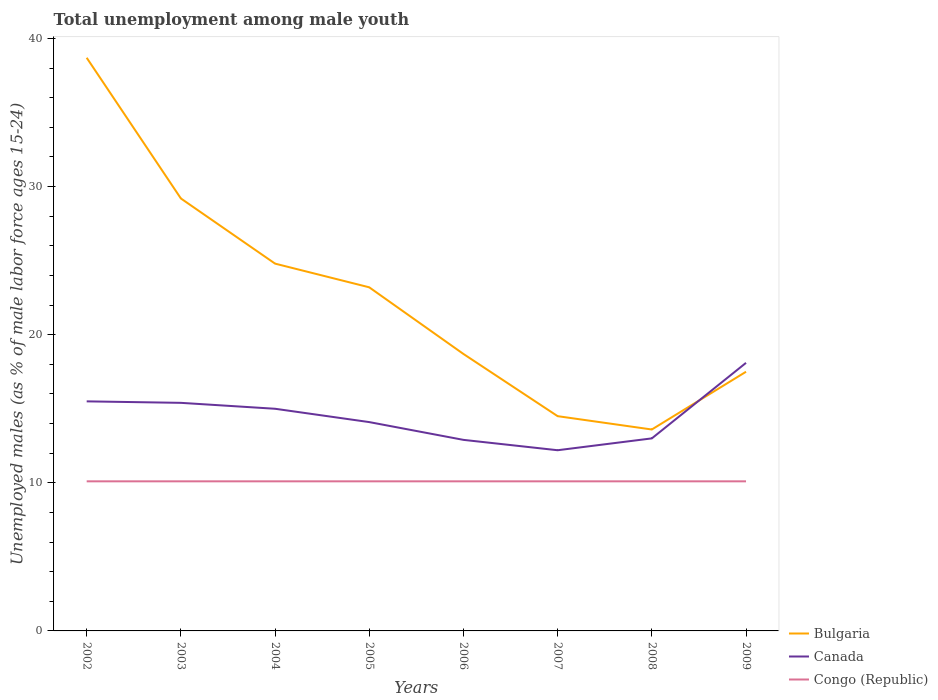How many different coloured lines are there?
Provide a succinct answer. 3. Does the line corresponding to Bulgaria intersect with the line corresponding to Canada?
Provide a succinct answer. Yes. Is the number of lines equal to the number of legend labels?
Your response must be concise. Yes. Across all years, what is the maximum percentage of unemployed males in in Canada?
Your answer should be compact. 12.2. In which year was the percentage of unemployed males in in Canada maximum?
Offer a terse response. 2007. What is the total percentage of unemployed males in in Bulgaria in the graph?
Your answer should be very brief. 24.2. What is the difference between the highest and the second highest percentage of unemployed males in in Congo (Republic)?
Provide a succinct answer. 0. Is the percentage of unemployed males in in Congo (Republic) strictly greater than the percentage of unemployed males in in Canada over the years?
Offer a terse response. Yes. How many years are there in the graph?
Offer a very short reply. 8. Are the values on the major ticks of Y-axis written in scientific E-notation?
Provide a short and direct response. No. Does the graph contain grids?
Offer a very short reply. No. Where does the legend appear in the graph?
Your answer should be very brief. Bottom right. How many legend labels are there?
Make the answer very short. 3. What is the title of the graph?
Your answer should be very brief. Total unemployment among male youth. Does "Faeroe Islands" appear as one of the legend labels in the graph?
Your response must be concise. No. What is the label or title of the Y-axis?
Give a very brief answer. Unemployed males (as % of male labor force ages 15-24). What is the Unemployed males (as % of male labor force ages 15-24) in Bulgaria in 2002?
Ensure brevity in your answer.  38.7. What is the Unemployed males (as % of male labor force ages 15-24) in Canada in 2002?
Offer a terse response. 15.5. What is the Unemployed males (as % of male labor force ages 15-24) in Congo (Republic) in 2002?
Provide a succinct answer. 10.1. What is the Unemployed males (as % of male labor force ages 15-24) in Bulgaria in 2003?
Make the answer very short. 29.2. What is the Unemployed males (as % of male labor force ages 15-24) of Canada in 2003?
Ensure brevity in your answer.  15.4. What is the Unemployed males (as % of male labor force ages 15-24) of Congo (Republic) in 2003?
Offer a very short reply. 10.1. What is the Unemployed males (as % of male labor force ages 15-24) of Bulgaria in 2004?
Your answer should be very brief. 24.8. What is the Unemployed males (as % of male labor force ages 15-24) in Canada in 2004?
Provide a short and direct response. 15. What is the Unemployed males (as % of male labor force ages 15-24) in Congo (Republic) in 2004?
Your answer should be compact. 10.1. What is the Unemployed males (as % of male labor force ages 15-24) of Bulgaria in 2005?
Your answer should be very brief. 23.2. What is the Unemployed males (as % of male labor force ages 15-24) in Canada in 2005?
Keep it short and to the point. 14.1. What is the Unemployed males (as % of male labor force ages 15-24) of Congo (Republic) in 2005?
Make the answer very short. 10.1. What is the Unemployed males (as % of male labor force ages 15-24) in Bulgaria in 2006?
Provide a short and direct response. 18.7. What is the Unemployed males (as % of male labor force ages 15-24) of Canada in 2006?
Your answer should be very brief. 12.9. What is the Unemployed males (as % of male labor force ages 15-24) in Congo (Republic) in 2006?
Ensure brevity in your answer.  10.1. What is the Unemployed males (as % of male labor force ages 15-24) of Bulgaria in 2007?
Offer a very short reply. 14.5. What is the Unemployed males (as % of male labor force ages 15-24) of Canada in 2007?
Give a very brief answer. 12.2. What is the Unemployed males (as % of male labor force ages 15-24) in Congo (Republic) in 2007?
Make the answer very short. 10.1. What is the Unemployed males (as % of male labor force ages 15-24) in Bulgaria in 2008?
Your answer should be very brief. 13.6. What is the Unemployed males (as % of male labor force ages 15-24) of Congo (Republic) in 2008?
Your answer should be very brief. 10.1. What is the Unemployed males (as % of male labor force ages 15-24) in Bulgaria in 2009?
Provide a succinct answer. 17.5. What is the Unemployed males (as % of male labor force ages 15-24) of Canada in 2009?
Your answer should be very brief. 18.1. What is the Unemployed males (as % of male labor force ages 15-24) of Congo (Republic) in 2009?
Your answer should be compact. 10.1. Across all years, what is the maximum Unemployed males (as % of male labor force ages 15-24) of Bulgaria?
Offer a terse response. 38.7. Across all years, what is the maximum Unemployed males (as % of male labor force ages 15-24) in Canada?
Make the answer very short. 18.1. Across all years, what is the maximum Unemployed males (as % of male labor force ages 15-24) of Congo (Republic)?
Your answer should be very brief. 10.1. Across all years, what is the minimum Unemployed males (as % of male labor force ages 15-24) of Bulgaria?
Provide a succinct answer. 13.6. Across all years, what is the minimum Unemployed males (as % of male labor force ages 15-24) of Canada?
Keep it short and to the point. 12.2. Across all years, what is the minimum Unemployed males (as % of male labor force ages 15-24) in Congo (Republic)?
Provide a succinct answer. 10.1. What is the total Unemployed males (as % of male labor force ages 15-24) of Bulgaria in the graph?
Ensure brevity in your answer.  180.2. What is the total Unemployed males (as % of male labor force ages 15-24) of Canada in the graph?
Give a very brief answer. 116.2. What is the total Unemployed males (as % of male labor force ages 15-24) of Congo (Republic) in the graph?
Give a very brief answer. 80.8. What is the difference between the Unemployed males (as % of male labor force ages 15-24) in Bulgaria in 2002 and that in 2003?
Give a very brief answer. 9.5. What is the difference between the Unemployed males (as % of male labor force ages 15-24) in Bulgaria in 2002 and that in 2004?
Provide a short and direct response. 13.9. What is the difference between the Unemployed males (as % of male labor force ages 15-24) in Canada in 2002 and that in 2004?
Make the answer very short. 0.5. What is the difference between the Unemployed males (as % of male labor force ages 15-24) of Bulgaria in 2002 and that in 2005?
Offer a terse response. 15.5. What is the difference between the Unemployed males (as % of male labor force ages 15-24) of Congo (Republic) in 2002 and that in 2005?
Keep it short and to the point. 0. What is the difference between the Unemployed males (as % of male labor force ages 15-24) in Bulgaria in 2002 and that in 2006?
Your answer should be very brief. 20. What is the difference between the Unemployed males (as % of male labor force ages 15-24) of Congo (Republic) in 2002 and that in 2006?
Provide a short and direct response. 0. What is the difference between the Unemployed males (as % of male labor force ages 15-24) in Bulgaria in 2002 and that in 2007?
Keep it short and to the point. 24.2. What is the difference between the Unemployed males (as % of male labor force ages 15-24) in Canada in 2002 and that in 2007?
Your response must be concise. 3.3. What is the difference between the Unemployed males (as % of male labor force ages 15-24) in Congo (Republic) in 2002 and that in 2007?
Ensure brevity in your answer.  0. What is the difference between the Unemployed males (as % of male labor force ages 15-24) of Bulgaria in 2002 and that in 2008?
Your response must be concise. 25.1. What is the difference between the Unemployed males (as % of male labor force ages 15-24) of Canada in 2002 and that in 2008?
Offer a terse response. 2.5. What is the difference between the Unemployed males (as % of male labor force ages 15-24) of Bulgaria in 2002 and that in 2009?
Offer a terse response. 21.2. What is the difference between the Unemployed males (as % of male labor force ages 15-24) in Canada in 2002 and that in 2009?
Make the answer very short. -2.6. What is the difference between the Unemployed males (as % of male labor force ages 15-24) in Congo (Republic) in 2003 and that in 2004?
Give a very brief answer. 0. What is the difference between the Unemployed males (as % of male labor force ages 15-24) in Canada in 2003 and that in 2005?
Give a very brief answer. 1.3. What is the difference between the Unemployed males (as % of male labor force ages 15-24) of Bulgaria in 2003 and that in 2006?
Give a very brief answer. 10.5. What is the difference between the Unemployed males (as % of male labor force ages 15-24) in Canada in 2003 and that in 2006?
Provide a succinct answer. 2.5. What is the difference between the Unemployed males (as % of male labor force ages 15-24) of Bulgaria in 2003 and that in 2007?
Ensure brevity in your answer.  14.7. What is the difference between the Unemployed males (as % of male labor force ages 15-24) in Congo (Republic) in 2003 and that in 2009?
Offer a terse response. 0. What is the difference between the Unemployed males (as % of male labor force ages 15-24) in Bulgaria in 2004 and that in 2005?
Make the answer very short. 1.6. What is the difference between the Unemployed males (as % of male labor force ages 15-24) of Bulgaria in 2004 and that in 2006?
Give a very brief answer. 6.1. What is the difference between the Unemployed males (as % of male labor force ages 15-24) in Congo (Republic) in 2004 and that in 2006?
Offer a terse response. 0. What is the difference between the Unemployed males (as % of male labor force ages 15-24) of Bulgaria in 2004 and that in 2007?
Offer a very short reply. 10.3. What is the difference between the Unemployed males (as % of male labor force ages 15-24) of Canada in 2004 and that in 2007?
Offer a very short reply. 2.8. What is the difference between the Unemployed males (as % of male labor force ages 15-24) in Congo (Republic) in 2004 and that in 2007?
Your answer should be very brief. 0. What is the difference between the Unemployed males (as % of male labor force ages 15-24) in Bulgaria in 2004 and that in 2008?
Offer a very short reply. 11.2. What is the difference between the Unemployed males (as % of male labor force ages 15-24) of Canada in 2004 and that in 2008?
Make the answer very short. 2. What is the difference between the Unemployed males (as % of male labor force ages 15-24) of Bulgaria in 2004 and that in 2009?
Offer a terse response. 7.3. What is the difference between the Unemployed males (as % of male labor force ages 15-24) of Congo (Republic) in 2004 and that in 2009?
Offer a terse response. 0. What is the difference between the Unemployed males (as % of male labor force ages 15-24) of Bulgaria in 2005 and that in 2006?
Keep it short and to the point. 4.5. What is the difference between the Unemployed males (as % of male labor force ages 15-24) in Canada in 2005 and that in 2006?
Keep it short and to the point. 1.2. What is the difference between the Unemployed males (as % of male labor force ages 15-24) in Congo (Republic) in 2005 and that in 2006?
Your response must be concise. 0. What is the difference between the Unemployed males (as % of male labor force ages 15-24) of Canada in 2005 and that in 2007?
Provide a short and direct response. 1.9. What is the difference between the Unemployed males (as % of male labor force ages 15-24) in Congo (Republic) in 2005 and that in 2007?
Provide a succinct answer. 0. What is the difference between the Unemployed males (as % of male labor force ages 15-24) of Congo (Republic) in 2005 and that in 2008?
Your answer should be compact. 0. What is the difference between the Unemployed males (as % of male labor force ages 15-24) of Canada in 2005 and that in 2009?
Give a very brief answer. -4. What is the difference between the Unemployed males (as % of male labor force ages 15-24) of Congo (Republic) in 2005 and that in 2009?
Make the answer very short. 0. What is the difference between the Unemployed males (as % of male labor force ages 15-24) in Bulgaria in 2006 and that in 2009?
Offer a very short reply. 1.2. What is the difference between the Unemployed males (as % of male labor force ages 15-24) of Congo (Republic) in 2007 and that in 2008?
Offer a terse response. 0. What is the difference between the Unemployed males (as % of male labor force ages 15-24) in Bulgaria in 2007 and that in 2009?
Keep it short and to the point. -3. What is the difference between the Unemployed males (as % of male labor force ages 15-24) of Bulgaria in 2008 and that in 2009?
Provide a succinct answer. -3.9. What is the difference between the Unemployed males (as % of male labor force ages 15-24) of Bulgaria in 2002 and the Unemployed males (as % of male labor force ages 15-24) of Canada in 2003?
Your response must be concise. 23.3. What is the difference between the Unemployed males (as % of male labor force ages 15-24) in Bulgaria in 2002 and the Unemployed males (as % of male labor force ages 15-24) in Congo (Republic) in 2003?
Keep it short and to the point. 28.6. What is the difference between the Unemployed males (as % of male labor force ages 15-24) of Canada in 2002 and the Unemployed males (as % of male labor force ages 15-24) of Congo (Republic) in 2003?
Give a very brief answer. 5.4. What is the difference between the Unemployed males (as % of male labor force ages 15-24) in Bulgaria in 2002 and the Unemployed males (as % of male labor force ages 15-24) in Canada in 2004?
Provide a succinct answer. 23.7. What is the difference between the Unemployed males (as % of male labor force ages 15-24) in Bulgaria in 2002 and the Unemployed males (as % of male labor force ages 15-24) in Congo (Republic) in 2004?
Provide a short and direct response. 28.6. What is the difference between the Unemployed males (as % of male labor force ages 15-24) in Bulgaria in 2002 and the Unemployed males (as % of male labor force ages 15-24) in Canada in 2005?
Ensure brevity in your answer.  24.6. What is the difference between the Unemployed males (as % of male labor force ages 15-24) of Bulgaria in 2002 and the Unemployed males (as % of male labor force ages 15-24) of Congo (Republic) in 2005?
Provide a short and direct response. 28.6. What is the difference between the Unemployed males (as % of male labor force ages 15-24) in Bulgaria in 2002 and the Unemployed males (as % of male labor force ages 15-24) in Canada in 2006?
Offer a terse response. 25.8. What is the difference between the Unemployed males (as % of male labor force ages 15-24) in Bulgaria in 2002 and the Unemployed males (as % of male labor force ages 15-24) in Congo (Republic) in 2006?
Ensure brevity in your answer.  28.6. What is the difference between the Unemployed males (as % of male labor force ages 15-24) of Bulgaria in 2002 and the Unemployed males (as % of male labor force ages 15-24) of Congo (Republic) in 2007?
Ensure brevity in your answer.  28.6. What is the difference between the Unemployed males (as % of male labor force ages 15-24) of Canada in 2002 and the Unemployed males (as % of male labor force ages 15-24) of Congo (Republic) in 2007?
Offer a very short reply. 5.4. What is the difference between the Unemployed males (as % of male labor force ages 15-24) of Bulgaria in 2002 and the Unemployed males (as % of male labor force ages 15-24) of Canada in 2008?
Your answer should be very brief. 25.7. What is the difference between the Unemployed males (as % of male labor force ages 15-24) in Bulgaria in 2002 and the Unemployed males (as % of male labor force ages 15-24) in Congo (Republic) in 2008?
Keep it short and to the point. 28.6. What is the difference between the Unemployed males (as % of male labor force ages 15-24) of Canada in 2002 and the Unemployed males (as % of male labor force ages 15-24) of Congo (Republic) in 2008?
Offer a terse response. 5.4. What is the difference between the Unemployed males (as % of male labor force ages 15-24) in Bulgaria in 2002 and the Unemployed males (as % of male labor force ages 15-24) in Canada in 2009?
Your answer should be very brief. 20.6. What is the difference between the Unemployed males (as % of male labor force ages 15-24) of Bulgaria in 2002 and the Unemployed males (as % of male labor force ages 15-24) of Congo (Republic) in 2009?
Give a very brief answer. 28.6. What is the difference between the Unemployed males (as % of male labor force ages 15-24) of Bulgaria in 2003 and the Unemployed males (as % of male labor force ages 15-24) of Congo (Republic) in 2004?
Offer a terse response. 19.1. What is the difference between the Unemployed males (as % of male labor force ages 15-24) of Canada in 2003 and the Unemployed males (as % of male labor force ages 15-24) of Congo (Republic) in 2004?
Your answer should be compact. 5.3. What is the difference between the Unemployed males (as % of male labor force ages 15-24) of Bulgaria in 2003 and the Unemployed males (as % of male labor force ages 15-24) of Canada in 2005?
Make the answer very short. 15.1. What is the difference between the Unemployed males (as % of male labor force ages 15-24) in Canada in 2003 and the Unemployed males (as % of male labor force ages 15-24) in Congo (Republic) in 2005?
Keep it short and to the point. 5.3. What is the difference between the Unemployed males (as % of male labor force ages 15-24) in Bulgaria in 2003 and the Unemployed males (as % of male labor force ages 15-24) in Canada in 2006?
Keep it short and to the point. 16.3. What is the difference between the Unemployed males (as % of male labor force ages 15-24) in Bulgaria in 2003 and the Unemployed males (as % of male labor force ages 15-24) in Canada in 2007?
Give a very brief answer. 17. What is the difference between the Unemployed males (as % of male labor force ages 15-24) of Bulgaria in 2003 and the Unemployed males (as % of male labor force ages 15-24) of Congo (Republic) in 2007?
Offer a very short reply. 19.1. What is the difference between the Unemployed males (as % of male labor force ages 15-24) in Canada in 2003 and the Unemployed males (as % of male labor force ages 15-24) in Congo (Republic) in 2007?
Give a very brief answer. 5.3. What is the difference between the Unemployed males (as % of male labor force ages 15-24) of Bulgaria in 2003 and the Unemployed males (as % of male labor force ages 15-24) of Canada in 2008?
Your answer should be compact. 16.2. What is the difference between the Unemployed males (as % of male labor force ages 15-24) of Bulgaria in 2003 and the Unemployed males (as % of male labor force ages 15-24) of Congo (Republic) in 2009?
Your answer should be compact. 19.1. What is the difference between the Unemployed males (as % of male labor force ages 15-24) of Bulgaria in 2004 and the Unemployed males (as % of male labor force ages 15-24) of Congo (Republic) in 2005?
Your answer should be compact. 14.7. What is the difference between the Unemployed males (as % of male labor force ages 15-24) in Bulgaria in 2004 and the Unemployed males (as % of male labor force ages 15-24) in Canada in 2006?
Give a very brief answer. 11.9. What is the difference between the Unemployed males (as % of male labor force ages 15-24) in Bulgaria in 2004 and the Unemployed males (as % of male labor force ages 15-24) in Canada in 2007?
Your answer should be very brief. 12.6. What is the difference between the Unemployed males (as % of male labor force ages 15-24) of Bulgaria in 2004 and the Unemployed males (as % of male labor force ages 15-24) of Congo (Republic) in 2007?
Offer a terse response. 14.7. What is the difference between the Unemployed males (as % of male labor force ages 15-24) of Canada in 2004 and the Unemployed males (as % of male labor force ages 15-24) of Congo (Republic) in 2007?
Give a very brief answer. 4.9. What is the difference between the Unemployed males (as % of male labor force ages 15-24) of Bulgaria in 2004 and the Unemployed males (as % of male labor force ages 15-24) of Canada in 2008?
Your answer should be very brief. 11.8. What is the difference between the Unemployed males (as % of male labor force ages 15-24) in Bulgaria in 2004 and the Unemployed males (as % of male labor force ages 15-24) in Canada in 2009?
Offer a very short reply. 6.7. What is the difference between the Unemployed males (as % of male labor force ages 15-24) in Bulgaria in 2004 and the Unemployed males (as % of male labor force ages 15-24) in Congo (Republic) in 2009?
Your response must be concise. 14.7. What is the difference between the Unemployed males (as % of male labor force ages 15-24) in Canada in 2004 and the Unemployed males (as % of male labor force ages 15-24) in Congo (Republic) in 2009?
Ensure brevity in your answer.  4.9. What is the difference between the Unemployed males (as % of male labor force ages 15-24) of Bulgaria in 2005 and the Unemployed males (as % of male labor force ages 15-24) of Canada in 2006?
Give a very brief answer. 10.3. What is the difference between the Unemployed males (as % of male labor force ages 15-24) in Bulgaria in 2005 and the Unemployed males (as % of male labor force ages 15-24) in Congo (Republic) in 2006?
Ensure brevity in your answer.  13.1. What is the difference between the Unemployed males (as % of male labor force ages 15-24) in Canada in 2005 and the Unemployed males (as % of male labor force ages 15-24) in Congo (Republic) in 2006?
Your answer should be compact. 4. What is the difference between the Unemployed males (as % of male labor force ages 15-24) in Canada in 2005 and the Unemployed males (as % of male labor force ages 15-24) in Congo (Republic) in 2007?
Your answer should be very brief. 4. What is the difference between the Unemployed males (as % of male labor force ages 15-24) in Bulgaria in 2005 and the Unemployed males (as % of male labor force ages 15-24) in Canada in 2008?
Ensure brevity in your answer.  10.2. What is the difference between the Unemployed males (as % of male labor force ages 15-24) in Bulgaria in 2005 and the Unemployed males (as % of male labor force ages 15-24) in Congo (Republic) in 2008?
Offer a very short reply. 13.1. What is the difference between the Unemployed males (as % of male labor force ages 15-24) of Bulgaria in 2005 and the Unemployed males (as % of male labor force ages 15-24) of Canada in 2009?
Provide a succinct answer. 5.1. What is the difference between the Unemployed males (as % of male labor force ages 15-24) in Bulgaria in 2005 and the Unemployed males (as % of male labor force ages 15-24) in Congo (Republic) in 2009?
Keep it short and to the point. 13.1. What is the difference between the Unemployed males (as % of male labor force ages 15-24) of Canada in 2006 and the Unemployed males (as % of male labor force ages 15-24) of Congo (Republic) in 2007?
Your answer should be compact. 2.8. What is the difference between the Unemployed males (as % of male labor force ages 15-24) of Canada in 2006 and the Unemployed males (as % of male labor force ages 15-24) of Congo (Republic) in 2008?
Your response must be concise. 2.8. What is the difference between the Unemployed males (as % of male labor force ages 15-24) in Canada in 2006 and the Unemployed males (as % of male labor force ages 15-24) in Congo (Republic) in 2009?
Your response must be concise. 2.8. What is the difference between the Unemployed males (as % of male labor force ages 15-24) in Bulgaria in 2007 and the Unemployed males (as % of male labor force ages 15-24) in Canada in 2008?
Keep it short and to the point. 1.5. What is the difference between the Unemployed males (as % of male labor force ages 15-24) of Bulgaria in 2007 and the Unemployed males (as % of male labor force ages 15-24) of Congo (Republic) in 2008?
Give a very brief answer. 4.4. What is the difference between the Unemployed males (as % of male labor force ages 15-24) in Canada in 2007 and the Unemployed males (as % of male labor force ages 15-24) in Congo (Republic) in 2008?
Offer a very short reply. 2.1. What is the difference between the Unemployed males (as % of male labor force ages 15-24) of Bulgaria in 2007 and the Unemployed males (as % of male labor force ages 15-24) of Canada in 2009?
Your response must be concise. -3.6. What is the difference between the Unemployed males (as % of male labor force ages 15-24) in Bulgaria in 2007 and the Unemployed males (as % of male labor force ages 15-24) in Congo (Republic) in 2009?
Offer a very short reply. 4.4. What is the difference between the Unemployed males (as % of male labor force ages 15-24) in Bulgaria in 2008 and the Unemployed males (as % of male labor force ages 15-24) in Canada in 2009?
Offer a very short reply. -4.5. What is the difference between the Unemployed males (as % of male labor force ages 15-24) in Bulgaria in 2008 and the Unemployed males (as % of male labor force ages 15-24) in Congo (Republic) in 2009?
Ensure brevity in your answer.  3.5. What is the difference between the Unemployed males (as % of male labor force ages 15-24) of Canada in 2008 and the Unemployed males (as % of male labor force ages 15-24) of Congo (Republic) in 2009?
Provide a short and direct response. 2.9. What is the average Unemployed males (as % of male labor force ages 15-24) in Bulgaria per year?
Your answer should be compact. 22.52. What is the average Unemployed males (as % of male labor force ages 15-24) of Canada per year?
Your answer should be very brief. 14.53. In the year 2002, what is the difference between the Unemployed males (as % of male labor force ages 15-24) of Bulgaria and Unemployed males (as % of male labor force ages 15-24) of Canada?
Ensure brevity in your answer.  23.2. In the year 2002, what is the difference between the Unemployed males (as % of male labor force ages 15-24) in Bulgaria and Unemployed males (as % of male labor force ages 15-24) in Congo (Republic)?
Give a very brief answer. 28.6. In the year 2003, what is the difference between the Unemployed males (as % of male labor force ages 15-24) of Bulgaria and Unemployed males (as % of male labor force ages 15-24) of Canada?
Offer a terse response. 13.8. In the year 2003, what is the difference between the Unemployed males (as % of male labor force ages 15-24) of Bulgaria and Unemployed males (as % of male labor force ages 15-24) of Congo (Republic)?
Your response must be concise. 19.1. In the year 2004, what is the difference between the Unemployed males (as % of male labor force ages 15-24) in Canada and Unemployed males (as % of male labor force ages 15-24) in Congo (Republic)?
Provide a short and direct response. 4.9. In the year 2006, what is the difference between the Unemployed males (as % of male labor force ages 15-24) of Bulgaria and Unemployed males (as % of male labor force ages 15-24) of Canada?
Your response must be concise. 5.8. In the year 2006, what is the difference between the Unemployed males (as % of male labor force ages 15-24) of Canada and Unemployed males (as % of male labor force ages 15-24) of Congo (Republic)?
Offer a very short reply. 2.8. In the year 2007, what is the difference between the Unemployed males (as % of male labor force ages 15-24) of Bulgaria and Unemployed males (as % of male labor force ages 15-24) of Congo (Republic)?
Your answer should be very brief. 4.4. In the year 2008, what is the difference between the Unemployed males (as % of male labor force ages 15-24) in Bulgaria and Unemployed males (as % of male labor force ages 15-24) in Congo (Republic)?
Make the answer very short. 3.5. What is the ratio of the Unemployed males (as % of male labor force ages 15-24) of Bulgaria in 2002 to that in 2003?
Offer a very short reply. 1.33. What is the ratio of the Unemployed males (as % of male labor force ages 15-24) of Congo (Republic) in 2002 to that in 2003?
Keep it short and to the point. 1. What is the ratio of the Unemployed males (as % of male labor force ages 15-24) in Bulgaria in 2002 to that in 2004?
Offer a terse response. 1.56. What is the ratio of the Unemployed males (as % of male labor force ages 15-24) of Congo (Republic) in 2002 to that in 2004?
Give a very brief answer. 1. What is the ratio of the Unemployed males (as % of male labor force ages 15-24) of Bulgaria in 2002 to that in 2005?
Make the answer very short. 1.67. What is the ratio of the Unemployed males (as % of male labor force ages 15-24) in Canada in 2002 to that in 2005?
Offer a very short reply. 1.1. What is the ratio of the Unemployed males (as % of male labor force ages 15-24) of Congo (Republic) in 2002 to that in 2005?
Offer a very short reply. 1. What is the ratio of the Unemployed males (as % of male labor force ages 15-24) of Bulgaria in 2002 to that in 2006?
Make the answer very short. 2.07. What is the ratio of the Unemployed males (as % of male labor force ages 15-24) in Canada in 2002 to that in 2006?
Offer a terse response. 1.2. What is the ratio of the Unemployed males (as % of male labor force ages 15-24) of Bulgaria in 2002 to that in 2007?
Your answer should be compact. 2.67. What is the ratio of the Unemployed males (as % of male labor force ages 15-24) of Canada in 2002 to that in 2007?
Your response must be concise. 1.27. What is the ratio of the Unemployed males (as % of male labor force ages 15-24) of Bulgaria in 2002 to that in 2008?
Give a very brief answer. 2.85. What is the ratio of the Unemployed males (as % of male labor force ages 15-24) of Canada in 2002 to that in 2008?
Your answer should be compact. 1.19. What is the ratio of the Unemployed males (as % of male labor force ages 15-24) of Bulgaria in 2002 to that in 2009?
Your answer should be compact. 2.21. What is the ratio of the Unemployed males (as % of male labor force ages 15-24) of Canada in 2002 to that in 2009?
Give a very brief answer. 0.86. What is the ratio of the Unemployed males (as % of male labor force ages 15-24) in Bulgaria in 2003 to that in 2004?
Offer a very short reply. 1.18. What is the ratio of the Unemployed males (as % of male labor force ages 15-24) of Canada in 2003 to that in 2004?
Provide a succinct answer. 1.03. What is the ratio of the Unemployed males (as % of male labor force ages 15-24) of Bulgaria in 2003 to that in 2005?
Your answer should be very brief. 1.26. What is the ratio of the Unemployed males (as % of male labor force ages 15-24) in Canada in 2003 to that in 2005?
Provide a succinct answer. 1.09. What is the ratio of the Unemployed males (as % of male labor force ages 15-24) in Bulgaria in 2003 to that in 2006?
Ensure brevity in your answer.  1.56. What is the ratio of the Unemployed males (as % of male labor force ages 15-24) of Canada in 2003 to that in 2006?
Your answer should be compact. 1.19. What is the ratio of the Unemployed males (as % of male labor force ages 15-24) of Bulgaria in 2003 to that in 2007?
Your answer should be compact. 2.01. What is the ratio of the Unemployed males (as % of male labor force ages 15-24) in Canada in 2003 to that in 2007?
Your answer should be compact. 1.26. What is the ratio of the Unemployed males (as % of male labor force ages 15-24) of Bulgaria in 2003 to that in 2008?
Your answer should be compact. 2.15. What is the ratio of the Unemployed males (as % of male labor force ages 15-24) of Canada in 2003 to that in 2008?
Provide a succinct answer. 1.18. What is the ratio of the Unemployed males (as % of male labor force ages 15-24) of Bulgaria in 2003 to that in 2009?
Provide a short and direct response. 1.67. What is the ratio of the Unemployed males (as % of male labor force ages 15-24) in Canada in 2003 to that in 2009?
Give a very brief answer. 0.85. What is the ratio of the Unemployed males (as % of male labor force ages 15-24) of Congo (Republic) in 2003 to that in 2009?
Offer a very short reply. 1. What is the ratio of the Unemployed males (as % of male labor force ages 15-24) in Bulgaria in 2004 to that in 2005?
Provide a succinct answer. 1.07. What is the ratio of the Unemployed males (as % of male labor force ages 15-24) of Canada in 2004 to that in 2005?
Make the answer very short. 1.06. What is the ratio of the Unemployed males (as % of male labor force ages 15-24) of Congo (Republic) in 2004 to that in 2005?
Provide a short and direct response. 1. What is the ratio of the Unemployed males (as % of male labor force ages 15-24) in Bulgaria in 2004 to that in 2006?
Your answer should be compact. 1.33. What is the ratio of the Unemployed males (as % of male labor force ages 15-24) of Canada in 2004 to that in 2006?
Ensure brevity in your answer.  1.16. What is the ratio of the Unemployed males (as % of male labor force ages 15-24) in Bulgaria in 2004 to that in 2007?
Give a very brief answer. 1.71. What is the ratio of the Unemployed males (as % of male labor force ages 15-24) of Canada in 2004 to that in 2007?
Offer a very short reply. 1.23. What is the ratio of the Unemployed males (as % of male labor force ages 15-24) in Congo (Republic) in 2004 to that in 2007?
Your answer should be compact. 1. What is the ratio of the Unemployed males (as % of male labor force ages 15-24) in Bulgaria in 2004 to that in 2008?
Keep it short and to the point. 1.82. What is the ratio of the Unemployed males (as % of male labor force ages 15-24) in Canada in 2004 to that in 2008?
Ensure brevity in your answer.  1.15. What is the ratio of the Unemployed males (as % of male labor force ages 15-24) of Congo (Republic) in 2004 to that in 2008?
Your response must be concise. 1. What is the ratio of the Unemployed males (as % of male labor force ages 15-24) of Bulgaria in 2004 to that in 2009?
Give a very brief answer. 1.42. What is the ratio of the Unemployed males (as % of male labor force ages 15-24) of Canada in 2004 to that in 2009?
Offer a very short reply. 0.83. What is the ratio of the Unemployed males (as % of male labor force ages 15-24) in Congo (Republic) in 2004 to that in 2009?
Make the answer very short. 1. What is the ratio of the Unemployed males (as % of male labor force ages 15-24) of Bulgaria in 2005 to that in 2006?
Your response must be concise. 1.24. What is the ratio of the Unemployed males (as % of male labor force ages 15-24) of Canada in 2005 to that in 2006?
Make the answer very short. 1.09. What is the ratio of the Unemployed males (as % of male labor force ages 15-24) in Congo (Republic) in 2005 to that in 2006?
Your response must be concise. 1. What is the ratio of the Unemployed males (as % of male labor force ages 15-24) in Bulgaria in 2005 to that in 2007?
Make the answer very short. 1.6. What is the ratio of the Unemployed males (as % of male labor force ages 15-24) of Canada in 2005 to that in 2007?
Offer a very short reply. 1.16. What is the ratio of the Unemployed males (as % of male labor force ages 15-24) of Bulgaria in 2005 to that in 2008?
Your answer should be very brief. 1.71. What is the ratio of the Unemployed males (as % of male labor force ages 15-24) in Canada in 2005 to that in 2008?
Offer a terse response. 1.08. What is the ratio of the Unemployed males (as % of male labor force ages 15-24) in Congo (Republic) in 2005 to that in 2008?
Your response must be concise. 1. What is the ratio of the Unemployed males (as % of male labor force ages 15-24) in Bulgaria in 2005 to that in 2009?
Give a very brief answer. 1.33. What is the ratio of the Unemployed males (as % of male labor force ages 15-24) in Canada in 2005 to that in 2009?
Your answer should be compact. 0.78. What is the ratio of the Unemployed males (as % of male labor force ages 15-24) of Bulgaria in 2006 to that in 2007?
Give a very brief answer. 1.29. What is the ratio of the Unemployed males (as % of male labor force ages 15-24) in Canada in 2006 to that in 2007?
Offer a terse response. 1.06. What is the ratio of the Unemployed males (as % of male labor force ages 15-24) of Bulgaria in 2006 to that in 2008?
Your answer should be very brief. 1.38. What is the ratio of the Unemployed males (as % of male labor force ages 15-24) in Bulgaria in 2006 to that in 2009?
Make the answer very short. 1.07. What is the ratio of the Unemployed males (as % of male labor force ages 15-24) in Canada in 2006 to that in 2009?
Give a very brief answer. 0.71. What is the ratio of the Unemployed males (as % of male labor force ages 15-24) of Bulgaria in 2007 to that in 2008?
Ensure brevity in your answer.  1.07. What is the ratio of the Unemployed males (as % of male labor force ages 15-24) of Canada in 2007 to that in 2008?
Offer a terse response. 0.94. What is the ratio of the Unemployed males (as % of male labor force ages 15-24) of Congo (Republic) in 2007 to that in 2008?
Provide a succinct answer. 1. What is the ratio of the Unemployed males (as % of male labor force ages 15-24) of Bulgaria in 2007 to that in 2009?
Your answer should be compact. 0.83. What is the ratio of the Unemployed males (as % of male labor force ages 15-24) in Canada in 2007 to that in 2009?
Ensure brevity in your answer.  0.67. What is the ratio of the Unemployed males (as % of male labor force ages 15-24) of Congo (Republic) in 2007 to that in 2009?
Your response must be concise. 1. What is the ratio of the Unemployed males (as % of male labor force ages 15-24) of Bulgaria in 2008 to that in 2009?
Your answer should be very brief. 0.78. What is the ratio of the Unemployed males (as % of male labor force ages 15-24) in Canada in 2008 to that in 2009?
Your answer should be compact. 0.72. What is the difference between the highest and the second highest Unemployed males (as % of male labor force ages 15-24) in Bulgaria?
Your response must be concise. 9.5. What is the difference between the highest and the second highest Unemployed males (as % of male labor force ages 15-24) of Canada?
Make the answer very short. 2.6. What is the difference between the highest and the second highest Unemployed males (as % of male labor force ages 15-24) in Congo (Republic)?
Provide a short and direct response. 0. What is the difference between the highest and the lowest Unemployed males (as % of male labor force ages 15-24) of Bulgaria?
Make the answer very short. 25.1. What is the difference between the highest and the lowest Unemployed males (as % of male labor force ages 15-24) of Canada?
Offer a terse response. 5.9. 